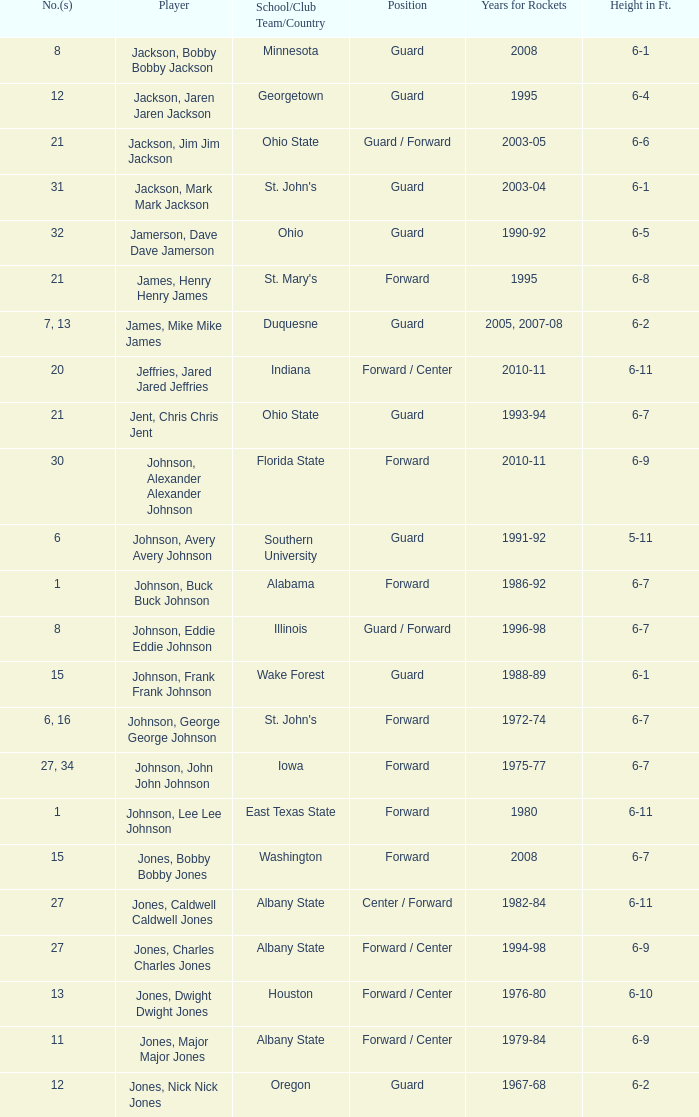Which player who played for the Rockets for the years 1986-92? Johnson, Buck Buck Johnson. 